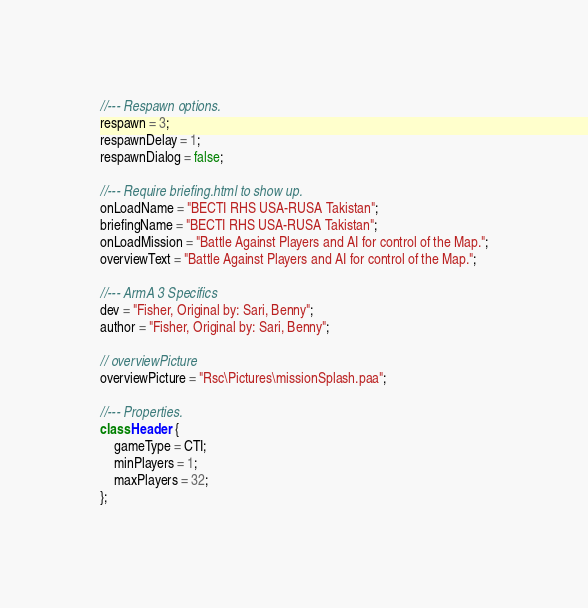<code> <loc_0><loc_0><loc_500><loc_500><_C++_>//--- Respawn options.
respawn = 3;
respawnDelay = 1;
respawnDialog = false;

//--- Require briefing.html to show up.
onLoadName = "BECTI RHS USA-RUSA Takistan";
briefingName = "BECTI RHS USA-RUSA Takistan";
onLoadMission = "Battle Against Players and AI for control of the Map.";
overviewText = "Battle Against Players and AI for control of the Map.";

//--- ArmA 3 Specifics
dev = "Fisher, Original by: Sari, Benny";
author = "Fisher, Original by: Sari, Benny";

// overviewPicture
overviewPicture = "Rsc\Pictures\missionSplash.paa";

//--- Properties.
class Header {
	gameType = CTI;
	minPlayers = 1;
	maxPlayers = 32;
};</code> 